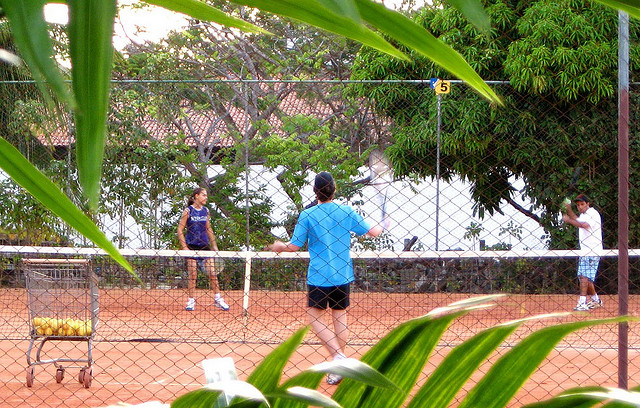Read and extract the text from this image. 5 